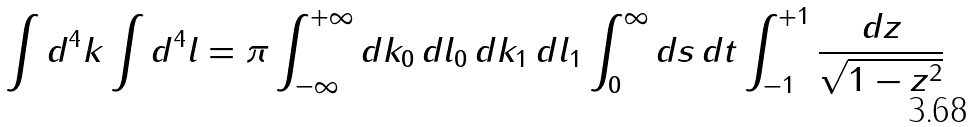<formula> <loc_0><loc_0><loc_500><loc_500>\int d ^ { 4 } k \int d ^ { 4 } l = \pi \int _ { - \infty } ^ { + \infty } d k _ { 0 } \, d l _ { 0 } \, d k _ { 1 } \, d l _ { 1 } \int _ { 0 } ^ { \infty } d s \, d t \int _ { - 1 } ^ { + 1 } \frac { d z } { \sqrt { 1 - z ^ { 2 } } }</formula> 